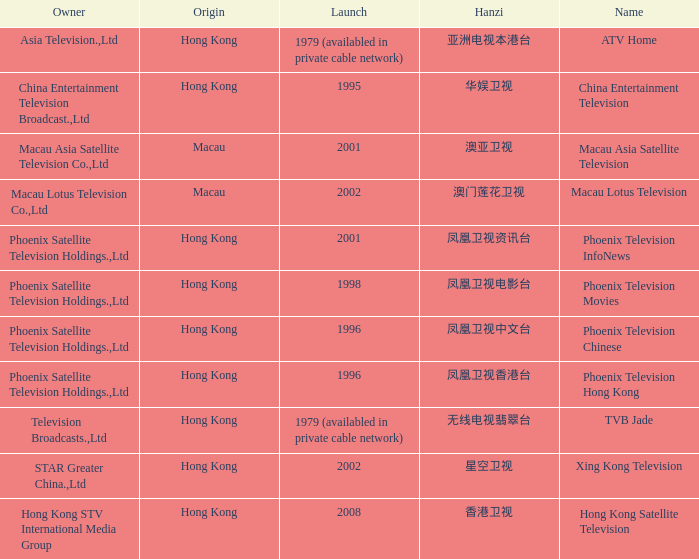What is the Hanzi of Phoenix Television Chinese that launched in 1996? 凤凰卫视中文台. 